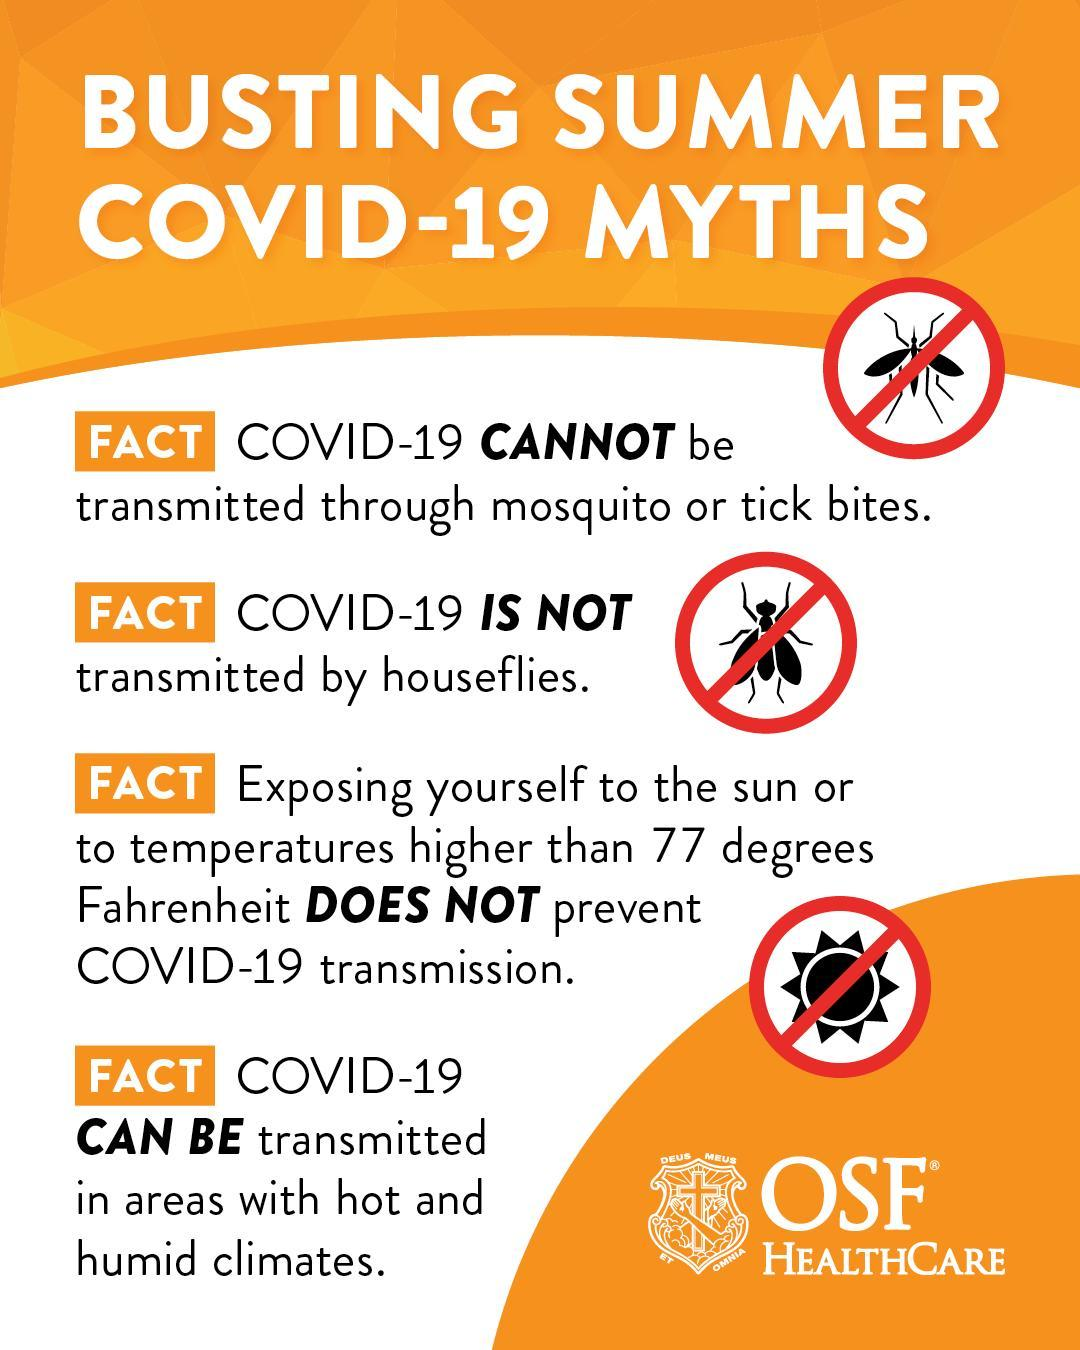How many insects are mentioned?
Answer the question with a short phrase. 3 Which insects are shown in the infographic? mosquito, houseflies 